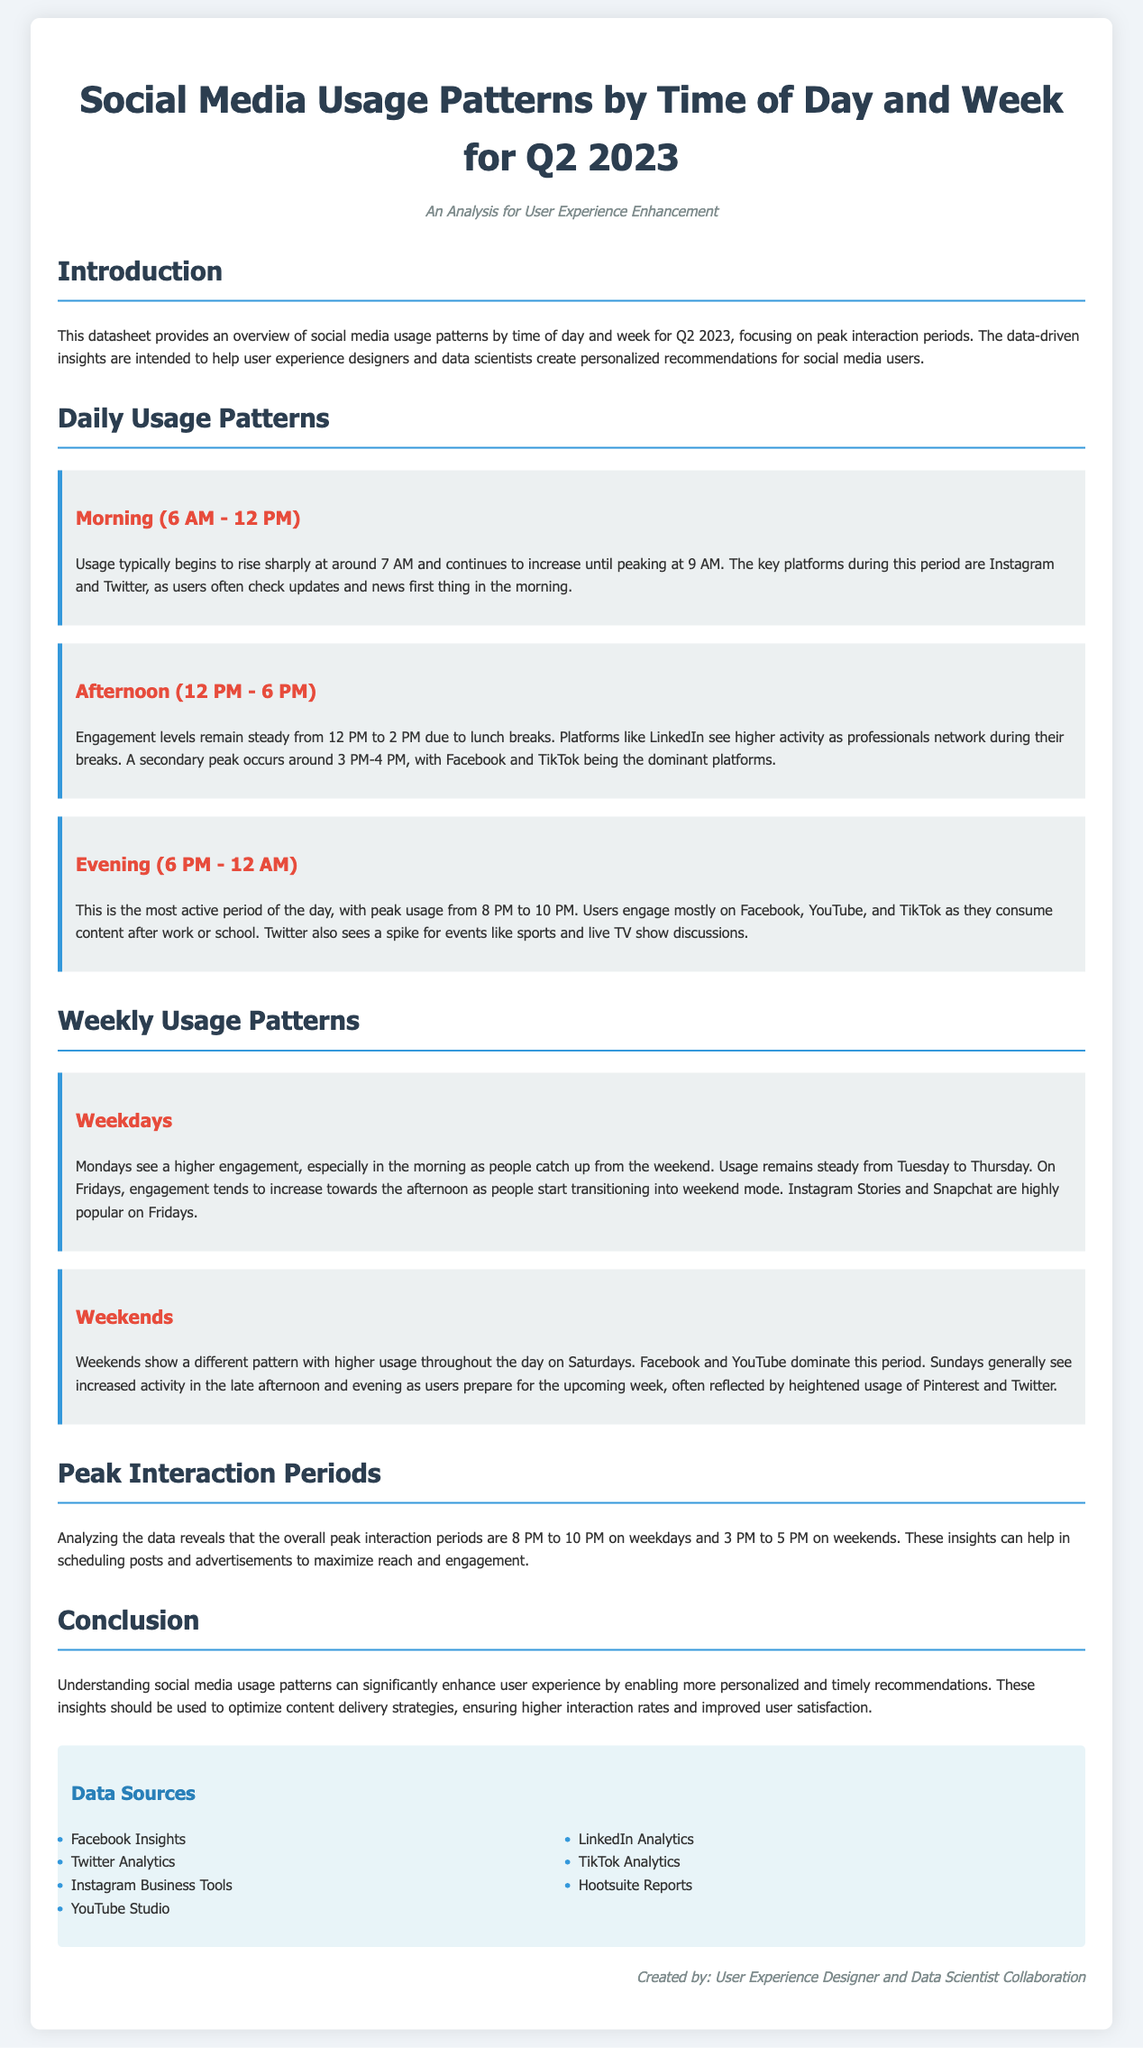what time does social media usage peak in the evening? The peak usage during the evening is specifically stated as occurring from 8 PM to 10 PM.
Answer: 8 PM to 10 PM which platforms are most used in the morning? The document mentions that Instagram and Twitter are the key platforms during the morning usage period.
Answer: Instagram and Twitter what weekday sees higher engagement in the morning? The analysis indicates that Mondays see higher engagement, especially in the morning.
Answer: Mondays what is the dominant platform during lunch breaks? The report specifies that LinkedIn sees higher activity during lunch breaks when engagement levels remain steady.
Answer: LinkedIn when does weekend activity generally peak? The document notes that weekends show higher usage throughout the day on Saturdays and increased activity on Sundays in the late afternoon and evening.
Answer: Saturdays what is the peak interaction period on weekends? The analysis specifies that 3 PM to 5 PM is identified as the peak interaction period during weekends.
Answer: 3 PM to 5 PM which platforms dominate weekend usage? The data content states that Facebook and YouTube dominate weekend usage.
Answer: Facebook and YouTube what time periods are crucial for scheduling posts? The report highlights that the overall peak interaction periods are 8 PM to 10 PM on weekdays and 3 PM to 5 PM on weekends.
Answer: 8 PM to 10 PM and 3 PM to 5 PM 